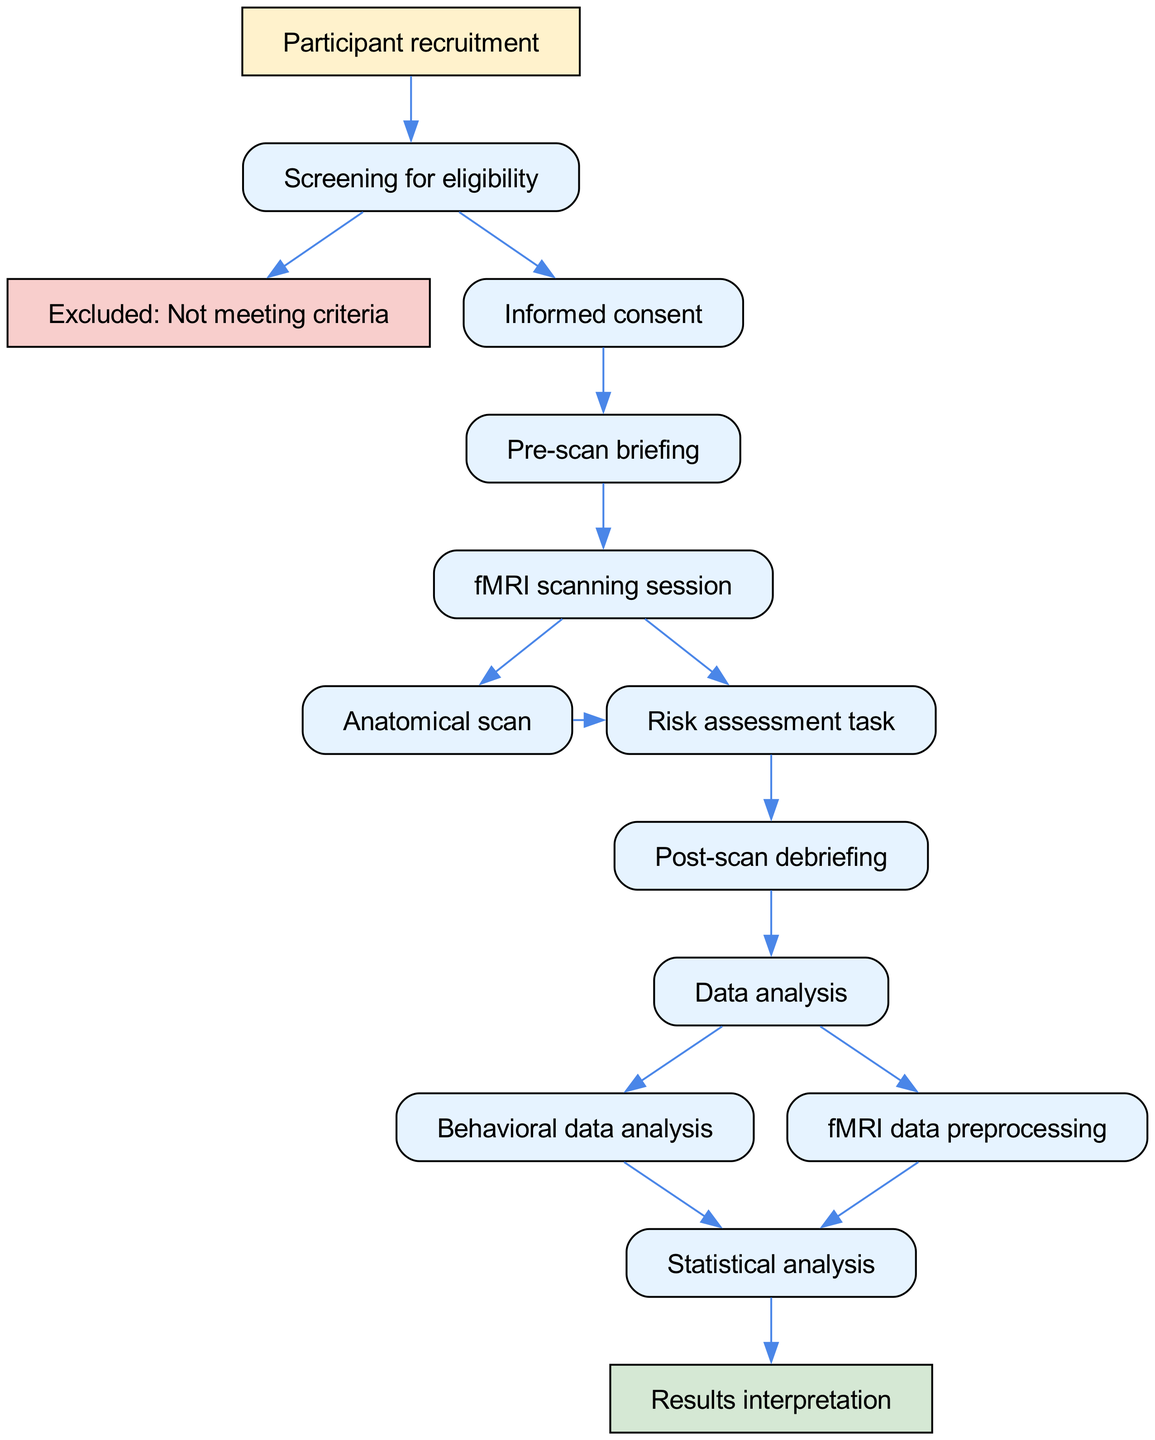What is the first step in the experimental protocol? The diagram shows that the first step in the experimental protocol is "Participant recruitment" as it is the starting node.
Answer: Participant recruitment How many steps are there before the fMRI scanning session? By examining the diagram, the steps leading to the fMRI scanning session are: 1) Participant recruitment, 2) Screening for eligibility, 3) Informed consent, 4) Pre-scan briefing. This totals to four steps before reaching the scanning session.
Answer: 4 What happens if the participant does not meet the eligibility criteria? The diagram indicates that if the participant is "Excluded: Not meeting criteria," it is a terminal step with no further actions, ending that branch of the protocol.
Answer: Excluded: Not meeting criteria What types of data analysis occur after the fMRI scanning session? According to the diagram, after the fMRI scanning session, there are two types of data analysis: 1) Behavioral data analysis, and 2) fMRI data preprocessing. Both connect to the next step "Statistical analysis."
Answer: Behavioral data analysis and fMRI data preprocessing What is the last step in the experimental protocol? The final node in the diagram is "Results interpretation," which signifies that it is the concluding action of the experimental protocol.
Answer: Results interpretation How are the nodes "Anatomical scan" and "Risk assessment task" connected in the diagram? The diagram shows that both nodes are sequential parts of the fMRI scanning session. After completing the "Anatomical scan," the flow proceeds directly to the "Risk assessment task," indicating their connection as part of the same broader fMRI session.
Answer: Sequential connection in the fMRI scanning session What are the two primary branches of analysis following data collection? Following the data collection, the diagram splits into two branches corresponding to the analysis of behavioral data and the preprocessing of fMRI data, which are both necessary for the subsequent statistical analysis.
Answer: Behavioral data analysis and fMRI data preprocessing What is the main purpose of the "Post-scan debriefing"? While the diagram doesn't explicitly state the purpose, it follows the risk assessment task. Typically, post-scan debriefing serves to explain the study to participants and gather feedback, making it a critical component of ethical research practices.
Answer: Typically ethical explanation and feedback collection 